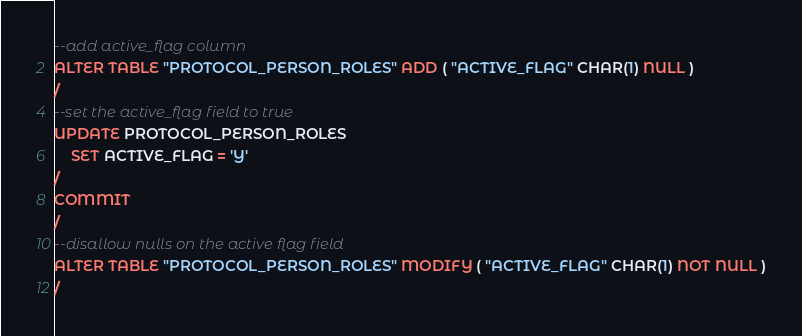<code> <loc_0><loc_0><loc_500><loc_500><_SQL_>--add active_flag column
ALTER TABLE "PROTOCOL_PERSON_ROLES" ADD ( "ACTIVE_FLAG" CHAR(1) NULL ) 
/
--set the active_flag field to true
UPDATE PROTOCOL_PERSON_ROLES
    SET ACTIVE_FLAG = 'Y'
/
COMMIT
/
--disallow nulls on the active flag field
ALTER TABLE "PROTOCOL_PERSON_ROLES" MODIFY ( "ACTIVE_FLAG" CHAR(1) NOT NULL )
/
</code> 